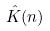<formula> <loc_0><loc_0><loc_500><loc_500>\hat { K } ( n )</formula> 